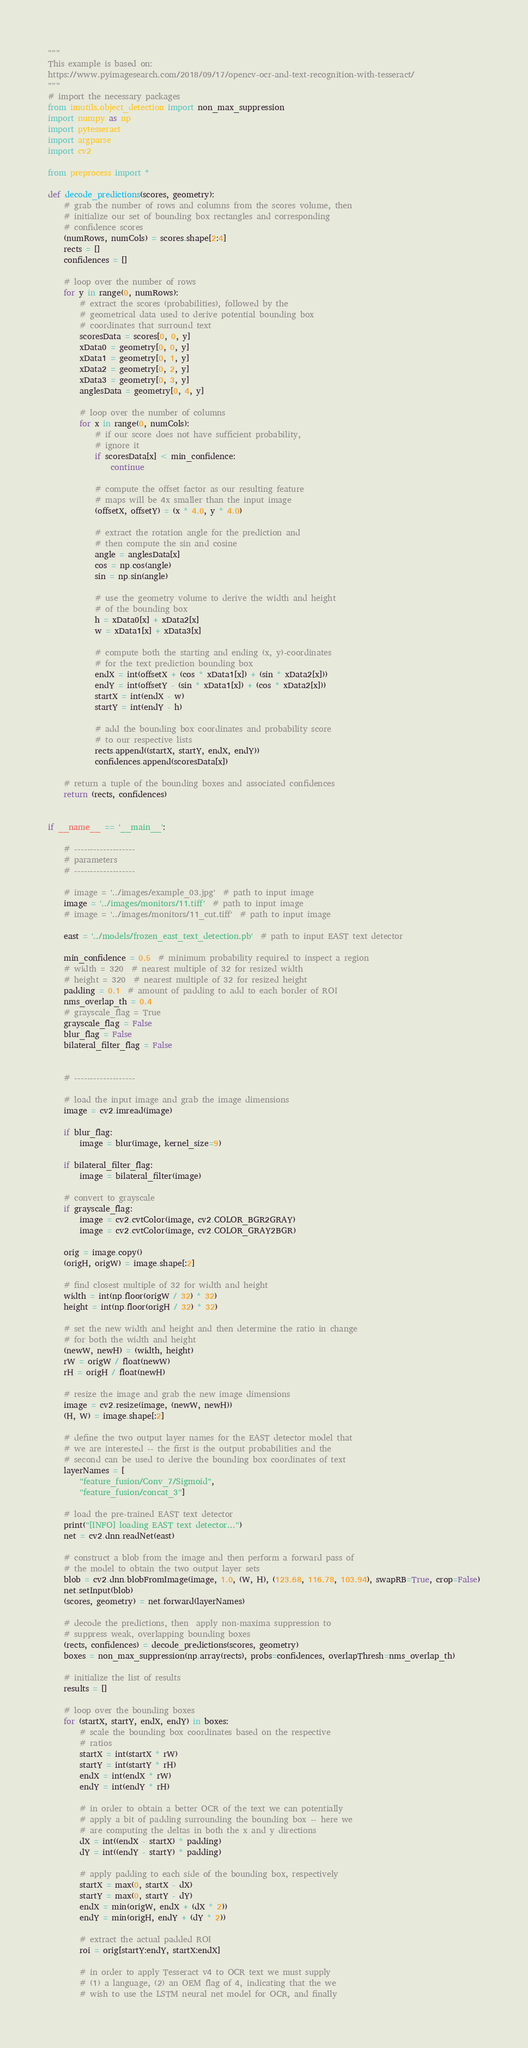Convert code to text. <code><loc_0><loc_0><loc_500><loc_500><_Python_>"""
This example is based on:
https://www.pyimagesearch.com/2018/09/17/opencv-ocr-and-text-recognition-with-tesseract/
"""
# import the necessary packages
from imutils.object_detection import non_max_suppression
import numpy as np
import pytesseract
import argparse
import cv2

from preprocess import *

def decode_predictions(scores, geometry):
    # grab the number of rows and columns from the scores volume, then
    # initialize our set of bounding box rectangles and corresponding
    # confidence scores
    (numRows, numCols) = scores.shape[2:4]
    rects = []
    confidences = []

    # loop over the number of rows
    for y in range(0, numRows):
        # extract the scores (probabilities), followed by the
        # geometrical data used to derive potential bounding box
        # coordinates that surround text
        scoresData = scores[0, 0, y]
        xData0 = geometry[0, 0, y]
        xData1 = geometry[0, 1, y]
        xData2 = geometry[0, 2, y]
        xData3 = geometry[0, 3, y]
        anglesData = geometry[0, 4, y]

        # loop over the number of columns
        for x in range(0, numCols):
            # if our score does not have sufficient probability,
            # ignore it
            if scoresData[x] < min_confidence:
                continue

            # compute the offset factor as our resulting feature
            # maps will be 4x smaller than the input image
            (offsetX, offsetY) = (x * 4.0, y * 4.0)

            # extract the rotation angle for the prediction and
            # then compute the sin and cosine
            angle = anglesData[x]
            cos = np.cos(angle)
            sin = np.sin(angle)

            # use the geometry volume to derive the width and height
            # of the bounding box
            h = xData0[x] + xData2[x]
            w = xData1[x] + xData3[x]

            # compute both the starting and ending (x, y)-coordinates
            # for the text prediction bounding box
            endX = int(offsetX + (cos * xData1[x]) + (sin * xData2[x]))
            endY = int(offsetY - (sin * xData1[x]) + (cos * xData2[x]))
            startX = int(endX - w)
            startY = int(endY - h)

            # add the bounding box coordinates and probability score
            # to our respective lists
            rects.append((startX, startY, endX, endY))
            confidences.append(scoresData[x])

    # return a tuple of the bounding boxes and associated confidences
    return (rects, confidences)


if __name__ == '__main__':

    # -------------------
    # parameters
    # -------------------

    # image = '../images/example_03.jpg'  # path to input image
    image = '../images/monitors/11.tiff'  # path to input image
    # image = '../images/monitors/11_cut.tiff'  # path to input image

    east = '../models/frozen_east_text_detection.pb'  # path to input EAST text detector

    min_confidence = 0.5  # minimum probability required to inspect a region
    # width = 320  # nearest multiple of 32 for resized width
    # height = 320  # nearest multiple of 32 for resized height
    padding = 0.1  # amount of padding to add to each border of ROI
    nms_overlap_th = 0.4
    # grayscale_flag = True
    grayscale_flag = False
    blur_flag = False
    bilateral_filter_flag = False


    # -------------------

    # load the input image and grab the image dimensions
    image = cv2.imread(image)

    if blur_flag:
        image = blur(image, kernel_size=9)

    if bilateral_filter_flag:
        image = bilateral_filter(image)

    # convert to grayscale
    if grayscale_flag:
        image = cv2.cvtColor(image, cv2.COLOR_BGR2GRAY)
        image = cv2.cvtColor(image, cv2.COLOR_GRAY2BGR)

    orig = image.copy()
    (origH, origW) = image.shape[:2]

    # find closest multiple of 32 for width and height
    width = int(np.floor(origW / 32) * 32)
    height = int(np.floor(origH / 32) * 32)

    # set the new width and height and then determine the ratio in change
    # for both the width and height
    (newW, newH) = (width, height)
    rW = origW / float(newW)
    rH = origH / float(newH)

    # resize the image and grab the new image dimensions
    image = cv2.resize(image, (newW, newH))
    (H, W) = image.shape[:2]

    # define the two output layer names for the EAST detector model that
    # we are interested -- the first is the output probabilities and the
    # second can be used to derive the bounding box coordinates of text
    layerNames = [
        "feature_fusion/Conv_7/Sigmoid",
        "feature_fusion/concat_3"]

    # load the pre-trained EAST text detector
    print("[INFO] loading EAST text detector...")
    net = cv2.dnn.readNet(east)

    # construct a blob from the image and then perform a forward pass of
    # the model to obtain the two output layer sets
    blob = cv2.dnn.blobFromImage(image, 1.0, (W, H), (123.68, 116.78, 103.94), swapRB=True, crop=False)
    net.setInput(blob)
    (scores, geometry) = net.forward(layerNames)

    # decode the predictions, then  apply non-maxima suppression to
    # suppress weak, overlapping bounding boxes
    (rects, confidences) = decode_predictions(scores, geometry)
    boxes = non_max_suppression(np.array(rects), probs=confidences, overlapThresh=nms_overlap_th)

    # initialize the list of results
    results = []

    # loop over the bounding boxes
    for (startX, startY, endX, endY) in boxes:
        # scale the bounding box coordinates based on the respective
        # ratios
        startX = int(startX * rW)
        startY = int(startY * rH)
        endX = int(endX * rW)
        endY = int(endY * rH)

        # in order to obtain a better OCR of the text we can potentially
        # apply a bit of padding surrounding the bounding box -- here we
        # are computing the deltas in both the x and y directions
        dX = int((endX - startX) * padding)
        dY = int((endY - startY) * padding)

        # apply padding to each side of the bounding box, respectively
        startX = max(0, startX - dX)
        startY = max(0, startY - dY)
        endX = min(origW, endX + (dX * 2))
        endY = min(origH, endY + (dY * 2))

        # extract the actual padded ROI
        roi = orig[startY:endY, startX:endX]

        # in order to apply Tesseract v4 to OCR text we must supply
        # (1) a language, (2) an OEM flag of 4, indicating that the we
        # wish to use the LSTM neural net model for OCR, and finally</code> 